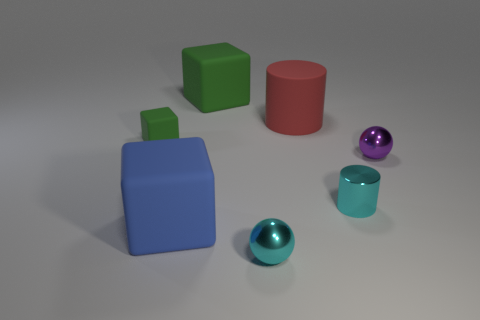Subtract all large blue blocks. How many blocks are left? 2 Add 2 tiny cylinders. How many objects exist? 9 Subtract all green balls. How many green cubes are left? 2 Subtract all cyan balls. How many balls are left? 1 Subtract all cylinders. How many objects are left? 5 Subtract all green spheres. Subtract all cyan cylinders. How many spheres are left? 2 Subtract all purple shiny balls. Subtract all purple metallic balls. How many objects are left? 5 Add 1 green matte things. How many green matte things are left? 3 Add 7 small cyan cylinders. How many small cyan cylinders exist? 8 Subtract 0 brown spheres. How many objects are left? 7 